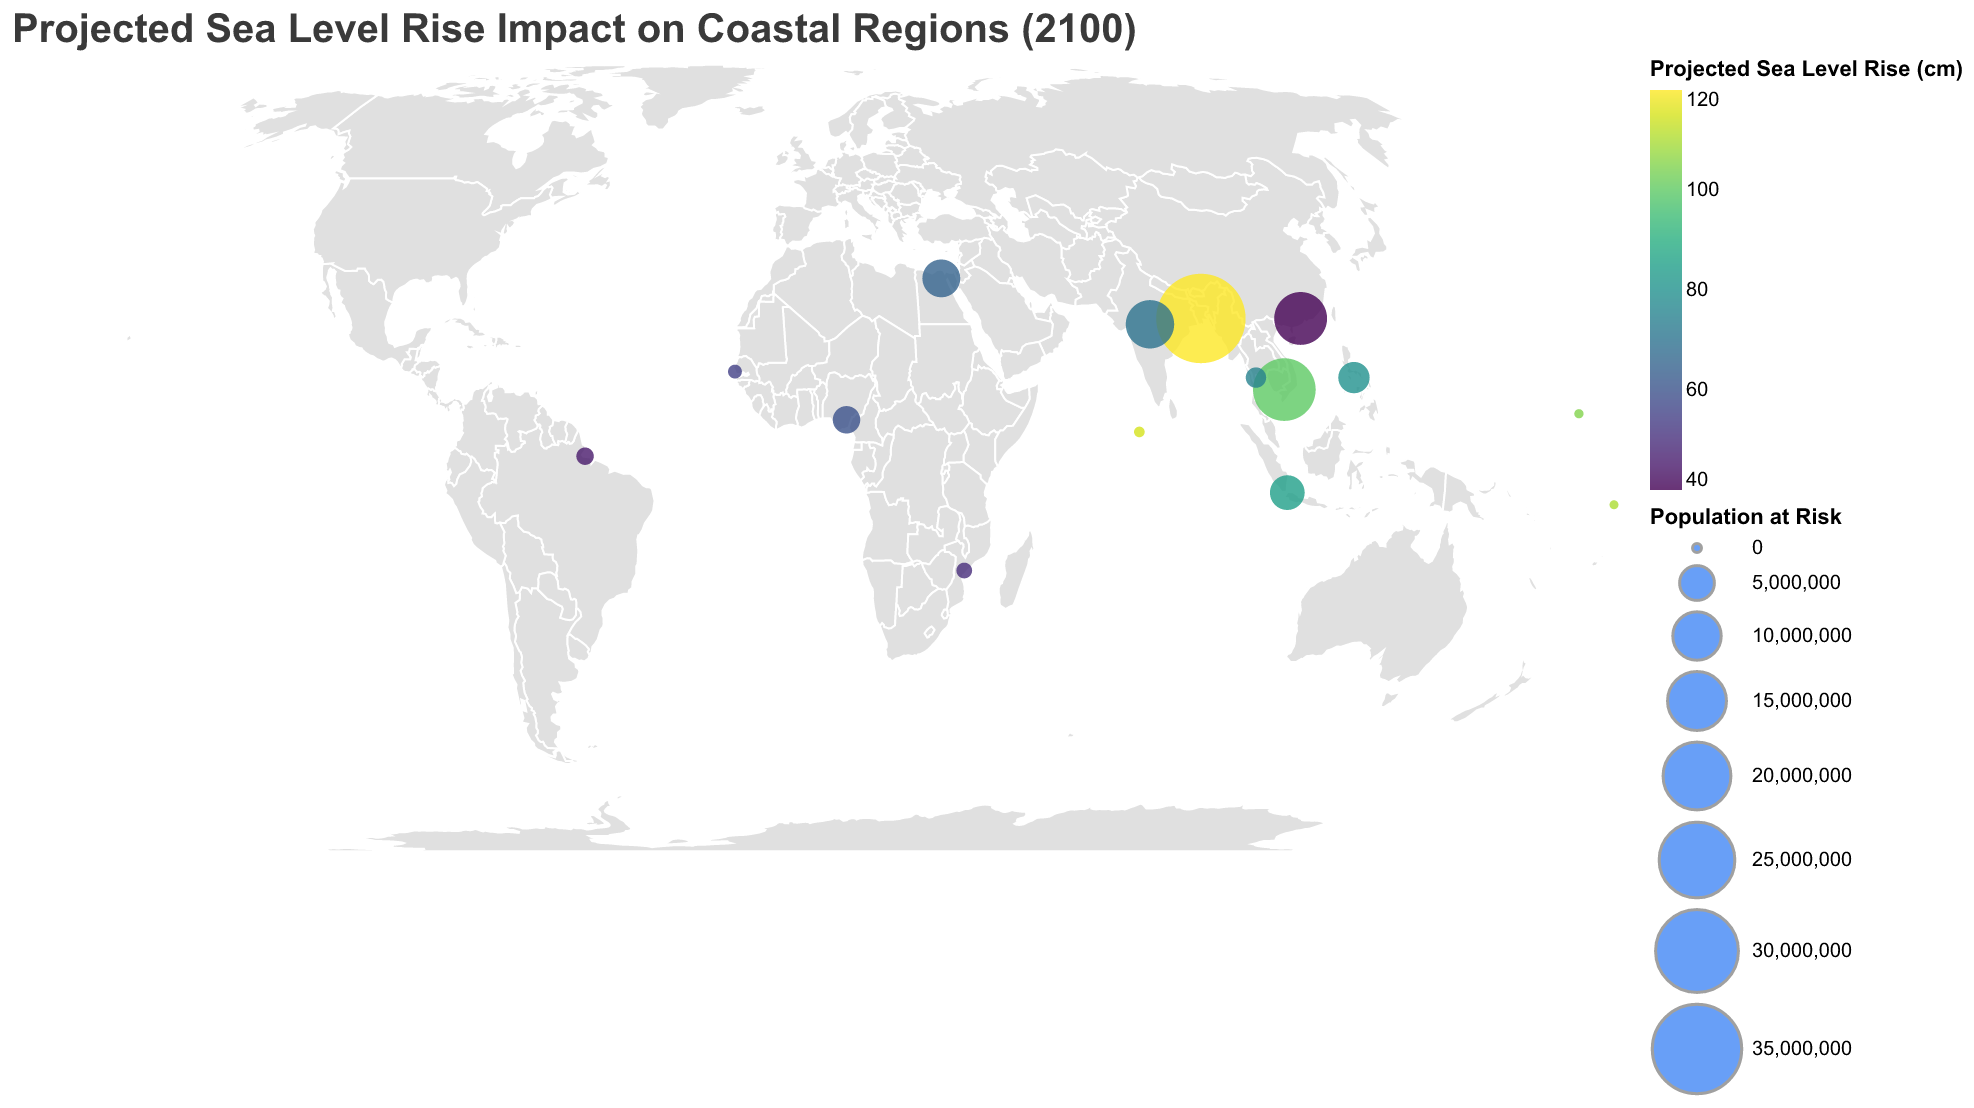How many regions are represented in the figure? By counting the number of distinct data points on the map, we can determine the total number of regions shown.
Answer: 15 Which region is projected to have the highest sea level rise by 2100? Look for the data point with the highest value in the "Projected Sea Level Rise (cm)" legend; it corresponds to Bangladesh.
Answer: Bangladesh How does the economic impact in the Nile Delta compare to that in Jakarta? The economic impact in the Nile Delta is $40 billion, while in Jakarta it is $60 billion. Comparing these values shows that Jakarta's economic impact is higher.
Answer: Jakarta has a higher economic impact Which region has the smallest population at risk, and what is that population? By examining the circles on the map, the smallest circle's tooltip reveals the population – this corresponds to Tuvalu, with a population at risk of 10,000.
Answer: Tuvalu, 10,000 What is the average projected sea level rise for the regions with more than 5 million people at risk? First, identify the regions with more than 5 million people at risk: Bangladesh (120 cm), Vietnam (100 cm), China (40 cm), and Egypt (65 cm). Calculate the average: (120 + 100 + 40 + 65) / 4
Answer: 81.25 cm Which regions are projected to have a sea level rise of over 100 cm? Look for regions in the color gradient that corresponds to values over 100 cm. These regions are Bangladesh, Maldives, Tuvalu, and Marshall Islands.
Answer: Bangladesh, Maldives, Tuvalu, Marshall Islands Compare the population at risk in Senegal and Philippines. Which is higher and by how much? Check the population at risk for both regions from the figure. Senegal has 500,000 people, and Philippines has 4,000,000 people. The difference is 4,000,000 - 500,000.
Answer: Philippines, 3,500,000 higher What is the total economic impact in regions with a projected sea level rise above 80 cm? Identify these regions: Bangladesh ($120 billion), Vietnam ($80 billion), Maldives ($5 billion), Tuvalu ($1 billion), Marshall Islands ($2 billion), Indonesia ($60 billion). The sum is 120 + 80 + 5 + 1 + 2 + 60.
Answer: $268 billion 